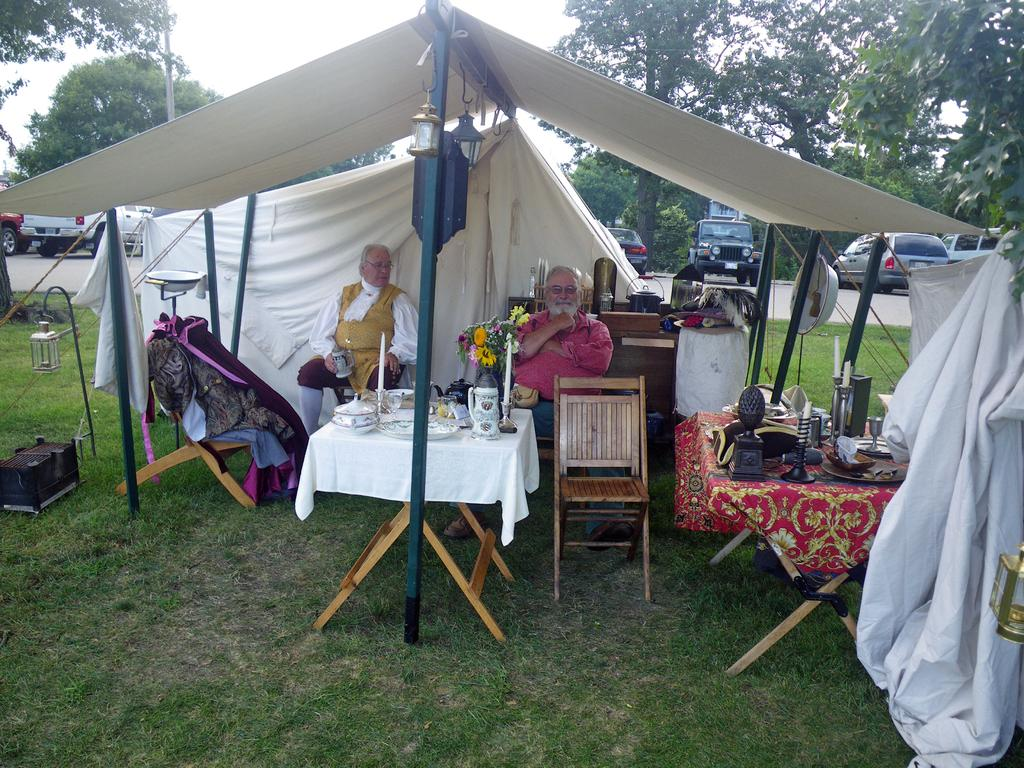How many people are in the image? There are two persons in the image. Where are the persons sitting? The persons are sitting under a white roof. What is in front of the persons? There is a table in front of the persons. What is the ground covered with? The ground is covered in greenery. What can be seen in the background of the image? There are cars and trees in the background of the image. What type of vegetable is being harvested at the hour depicted in the image? There is no vegetable harvesting or specific hour depicted in the image; it features two persons sitting under a white roof with a table in front of them. 